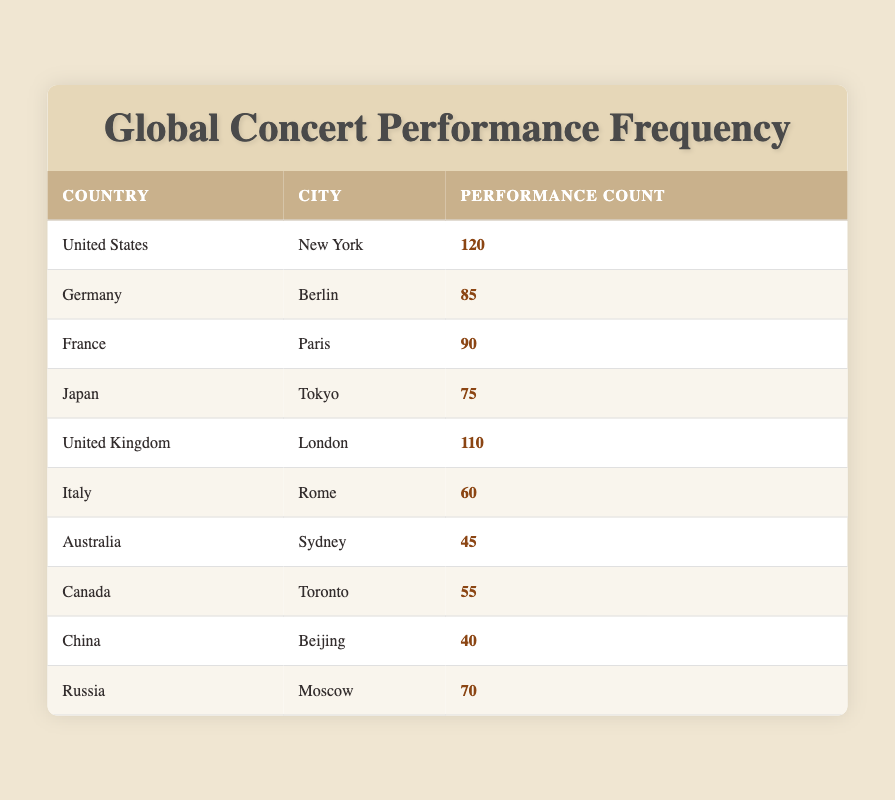What country has the highest number of concert performances? The table shows the performance counts for each country, and the United States has the highest performance count of 120 in New York.
Answer: United States How many performances were held in the United Kingdom? The table lists London under the United Kingdom with a performance count of 110.
Answer: 110 What is the average number of performances across all cities listed? To find the average, we sum all the performance counts (120 + 85 + 90 + 75 + 110 + 60 + 45 + 55 + 40 + 70 = 850) and divide by the number of cities (10). Thus, the average is 850/10 = 85.
Answer: 85 Is there a city in Australia with more performances than in China? Sydney has 45 performances while Beijing has 40 performances; therefore, yes, Sydney has more performances than Beijing.
Answer: Yes What is the difference in performance count between the highest and lowest performing city? The highest performing city is New York with 120 performances, and the lowest is Beijing with 40 performances. The difference is 120 - 40 = 80.
Answer: 80 How many more performances does Paris have compared to Toronto? Paris has 90 performances while Toronto has 55. The difference is 90 - 55 = 35.
Answer: 35 Which country had fewer concert performances: Russia or Italy? The performance count for Russia is 70 and for Italy it is 60. Since 70 is more than 60, Italy had fewer performances.
Answer: Italy How many cities have performance counts greater than 60? The cities with performance counts greater than 60 are New York (120), Berlin (85), Paris (90), London (110), and Tokyo (75). There are 5 such cities.
Answer: 5 